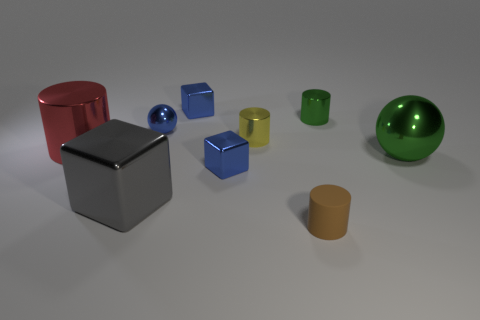There is a blue metal thing that is right of the shiny cube behind the blue metal sphere; what is its size?
Provide a short and direct response. Small. There is another rubber object that is the same shape as the small yellow object; what color is it?
Your response must be concise. Brown. Do the yellow object and the gray thing have the same size?
Provide a short and direct response. No. Is the number of yellow objects right of the green metallic cylinder the same as the number of large cyan rubber cubes?
Offer a terse response. Yes. There is a cylinder right of the tiny brown cylinder; are there any big shiny objects right of it?
Offer a very short reply. Yes. There is a cylinder that is to the left of the blue cube in front of the cylinder behind the tiny yellow object; what size is it?
Ensure brevity in your answer.  Large. The tiny cylinder in front of the gray cube that is to the left of the small ball is made of what material?
Your response must be concise. Rubber. Are there any large green metallic objects of the same shape as the tiny green shiny thing?
Offer a very short reply. No. The large green shiny thing has what shape?
Your answer should be very brief. Sphere. The sphere on the left side of the green metallic object to the right of the small thing to the right of the brown thing is made of what material?
Your answer should be compact. Metal. 